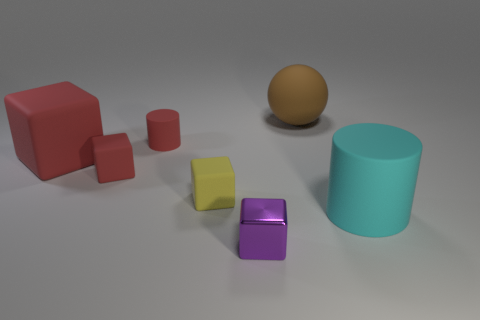Subtract all brown cylinders. How many red cubes are left? 2 Subtract all big matte cubes. How many cubes are left? 3 Subtract all yellow cubes. How many cubes are left? 3 Subtract all gray blocks. Subtract all blue balls. How many blocks are left? 4 Add 2 big red matte objects. How many objects exist? 9 Subtract all spheres. How many objects are left? 6 Subtract all metallic objects. Subtract all green metal cylinders. How many objects are left? 6 Add 3 small purple metallic objects. How many small purple metallic objects are left? 4 Add 7 tiny spheres. How many tiny spheres exist? 7 Subtract 0 yellow balls. How many objects are left? 7 